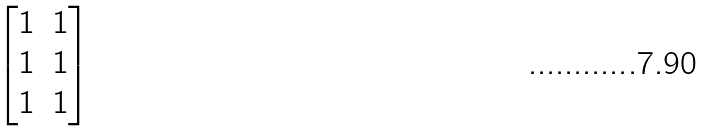<formula> <loc_0><loc_0><loc_500><loc_500>\begin{bmatrix} 1 & 1 \\ 1 & 1 \\ 1 & 1 \end{bmatrix}</formula> 